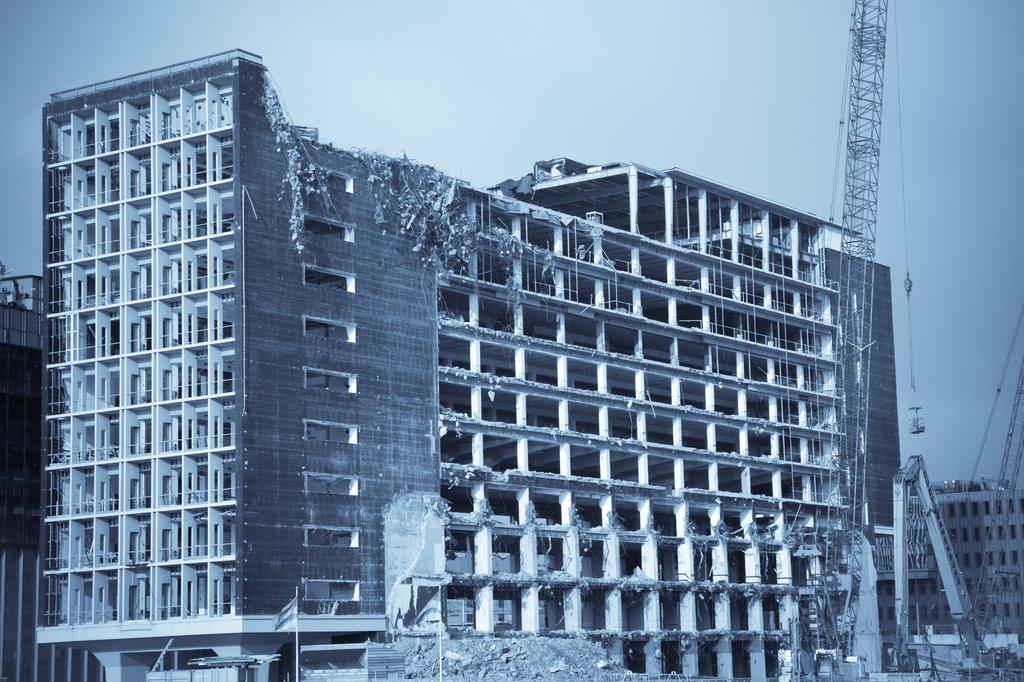What type of structures can be seen in the image? There are buildings in the image. What else is visible besides the buildings? There are rods and a vehicle visible in the image. How many flags are present in the image? There are 2 flags in the image. What can be seen in the background of the image? The sky is visible in the background of the image. What type of pin can be seen on the wrist of the person in the image? There is no person present in the image, and therefore no wrist or pin can be observed. 